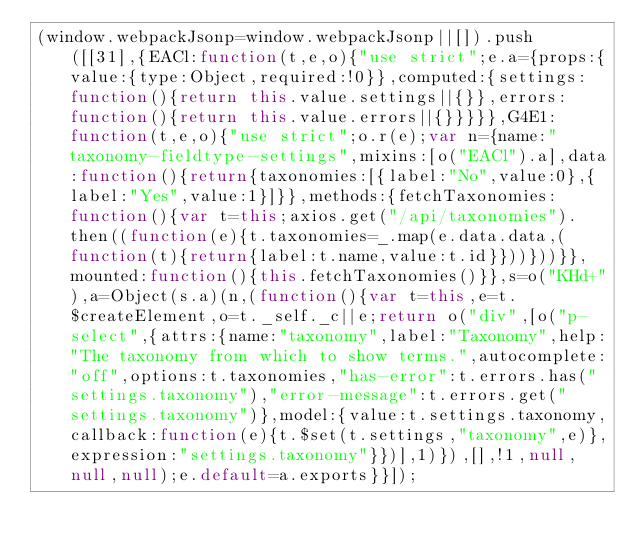<code> <loc_0><loc_0><loc_500><loc_500><_JavaScript_>(window.webpackJsonp=window.webpackJsonp||[]).push([[31],{EACl:function(t,e,o){"use strict";e.a={props:{value:{type:Object,required:!0}},computed:{settings:function(){return this.value.settings||{}},errors:function(){return this.value.errors||{}}}}},G4E1:function(t,e,o){"use strict";o.r(e);var n={name:"taxonomy-fieldtype-settings",mixins:[o("EACl").a],data:function(){return{taxonomies:[{label:"No",value:0},{label:"Yes",value:1}]}},methods:{fetchTaxonomies:function(){var t=this;axios.get("/api/taxonomies").then((function(e){t.taxonomies=_.map(e.data.data,(function(t){return{label:t.name,value:t.id}}))}))}},mounted:function(){this.fetchTaxonomies()}},s=o("KHd+"),a=Object(s.a)(n,(function(){var t=this,e=t.$createElement,o=t._self._c||e;return o("div",[o("p-select",{attrs:{name:"taxonomy",label:"Taxonomy",help:"The taxonomy from which to show terms.",autocomplete:"off",options:t.taxonomies,"has-error":t.errors.has("settings.taxonomy"),"error-message":t.errors.get("settings.taxonomy")},model:{value:t.settings.taxonomy,callback:function(e){t.$set(t.settings,"taxonomy",e)},expression:"settings.taxonomy"}})],1)}),[],!1,null,null,null);e.default=a.exports}}]);</code> 